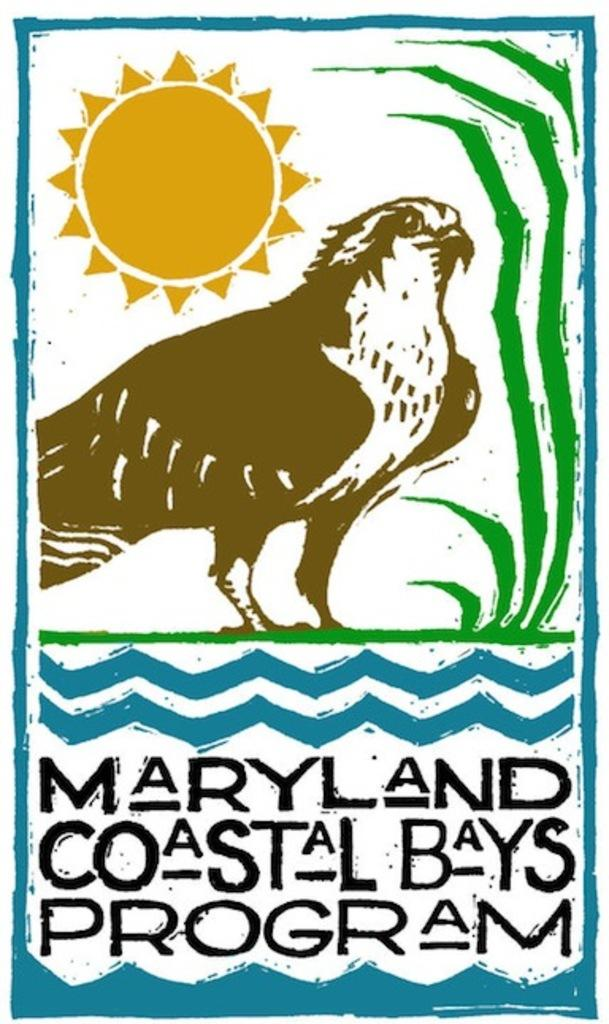What is depicted in the painting in the image? The painting contains a bird and a plant. What celestial body is featured in the painting? The painting features the sun. Are there any words or phrases written in the image? Yes, there are texts written at the bottom of the image. How does the wind affect the bird in the painting? There is no wind depicted in the painting; it only features a bird, a plant, and the sun. What type of loss is represented by the painting? The painting does not represent any type of loss; it is a depiction of a bird, a plant, and the sun. 